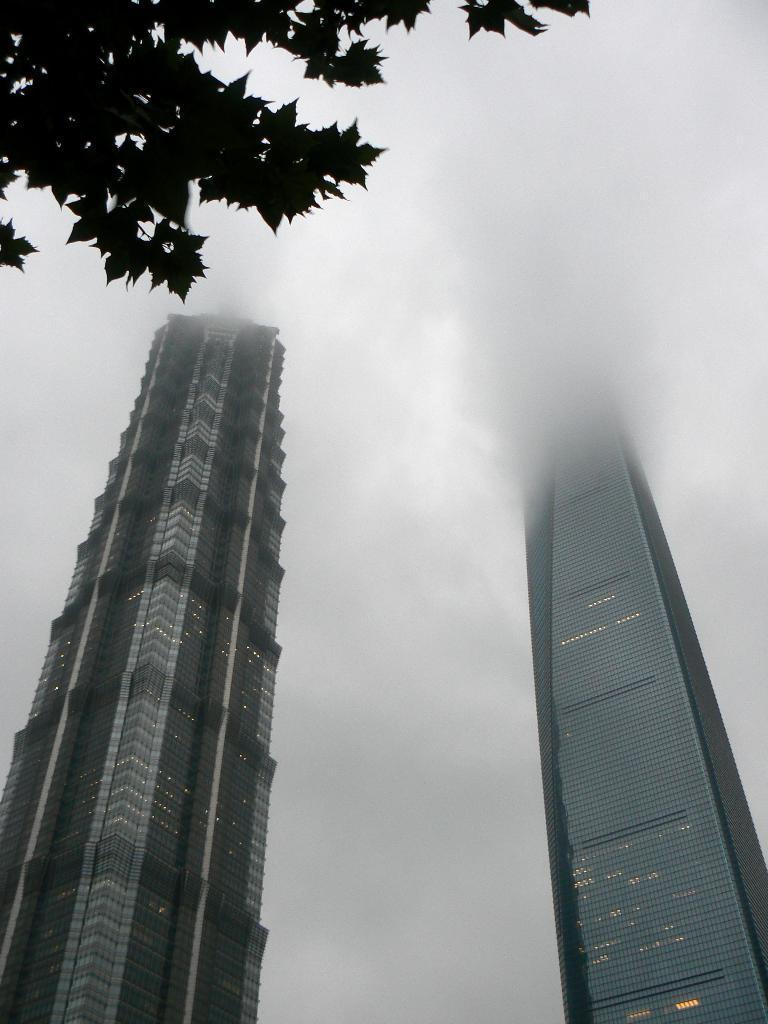Describe this image in one or two sentences. In this image we can see buildings, clouds in the sky and on the left side at the top we can see branches of a tree. 